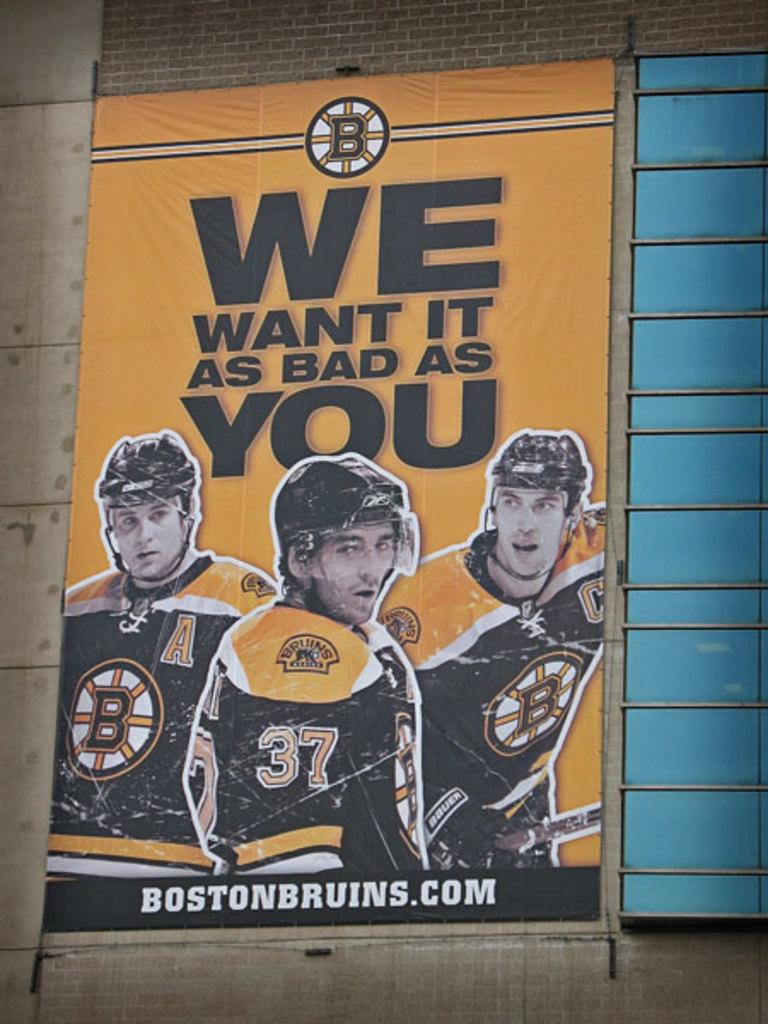<image>
Write a terse but informative summary of the picture. A poster for the Boston Bruins saying We Want It As Bad As You. 